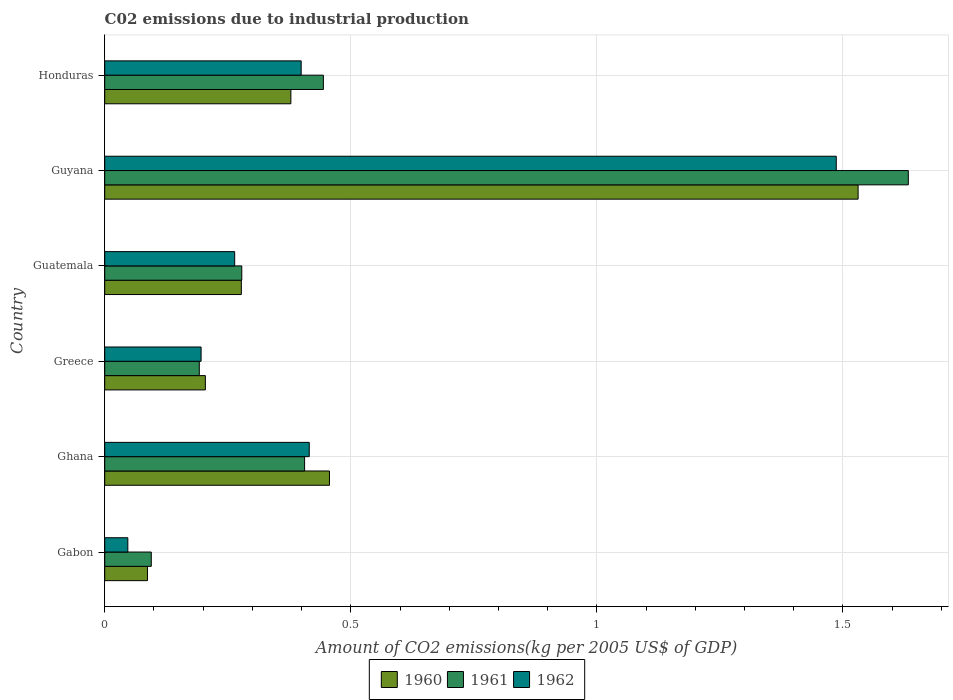How many groups of bars are there?
Keep it short and to the point. 6. What is the label of the 1st group of bars from the top?
Your answer should be very brief. Honduras. In how many cases, is the number of bars for a given country not equal to the number of legend labels?
Your answer should be compact. 0. What is the amount of CO2 emitted due to industrial production in 1961 in Honduras?
Your answer should be very brief. 0.44. Across all countries, what is the maximum amount of CO2 emitted due to industrial production in 1960?
Offer a terse response. 1.53. Across all countries, what is the minimum amount of CO2 emitted due to industrial production in 1960?
Your answer should be compact. 0.09. In which country was the amount of CO2 emitted due to industrial production in 1962 maximum?
Keep it short and to the point. Guyana. In which country was the amount of CO2 emitted due to industrial production in 1960 minimum?
Offer a terse response. Gabon. What is the total amount of CO2 emitted due to industrial production in 1962 in the graph?
Ensure brevity in your answer.  2.81. What is the difference between the amount of CO2 emitted due to industrial production in 1960 in Guatemala and that in Honduras?
Ensure brevity in your answer.  -0.1. What is the difference between the amount of CO2 emitted due to industrial production in 1962 in Guyana and the amount of CO2 emitted due to industrial production in 1961 in Greece?
Make the answer very short. 1.29. What is the average amount of CO2 emitted due to industrial production in 1962 per country?
Offer a terse response. 0.47. What is the difference between the amount of CO2 emitted due to industrial production in 1962 and amount of CO2 emitted due to industrial production in 1961 in Ghana?
Ensure brevity in your answer.  0.01. What is the ratio of the amount of CO2 emitted due to industrial production in 1961 in Greece to that in Guatemala?
Ensure brevity in your answer.  0.69. Is the amount of CO2 emitted due to industrial production in 1960 in Greece less than that in Guyana?
Ensure brevity in your answer.  Yes. Is the difference between the amount of CO2 emitted due to industrial production in 1962 in Gabon and Guatemala greater than the difference between the amount of CO2 emitted due to industrial production in 1961 in Gabon and Guatemala?
Give a very brief answer. No. What is the difference between the highest and the second highest amount of CO2 emitted due to industrial production in 1960?
Offer a very short reply. 1.07. What is the difference between the highest and the lowest amount of CO2 emitted due to industrial production in 1961?
Ensure brevity in your answer.  1.54. What does the 1st bar from the top in Honduras represents?
Keep it short and to the point. 1962. What does the 3rd bar from the bottom in Guatemala represents?
Provide a succinct answer. 1962. Are all the bars in the graph horizontal?
Give a very brief answer. Yes. How many countries are there in the graph?
Your answer should be compact. 6. Are the values on the major ticks of X-axis written in scientific E-notation?
Your answer should be very brief. No. Does the graph contain grids?
Offer a terse response. Yes. What is the title of the graph?
Your answer should be compact. C02 emissions due to industrial production. Does "2001" appear as one of the legend labels in the graph?
Your answer should be compact. No. What is the label or title of the X-axis?
Offer a very short reply. Amount of CO2 emissions(kg per 2005 US$ of GDP). What is the Amount of CO2 emissions(kg per 2005 US$ of GDP) in 1960 in Gabon?
Provide a short and direct response. 0.09. What is the Amount of CO2 emissions(kg per 2005 US$ of GDP) of 1961 in Gabon?
Offer a terse response. 0.09. What is the Amount of CO2 emissions(kg per 2005 US$ of GDP) in 1962 in Gabon?
Your answer should be very brief. 0.05. What is the Amount of CO2 emissions(kg per 2005 US$ of GDP) of 1960 in Ghana?
Offer a terse response. 0.46. What is the Amount of CO2 emissions(kg per 2005 US$ of GDP) of 1961 in Ghana?
Offer a very short reply. 0.41. What is the Amount of CO2 emissions(kg per 2005 US$ of GDP) in 1962 in Ghana?
Your answer should be compact. 0.42. What is the Amount of CO2 emissions(kg per 2005 US$ of GDP) of 1960 in Greece?
Offer a terse response. 0.2. What is the Amount of CO2 emissions(kg per 2005 US$ of GDP) of 1961 in Greece?
Ensure brevity in your answer.  0.19. What is the Amount of CO2 emissions(kg per 2005 US$ of GDP) of 1962 in Greece?
Your answer should be compact. 0.2. What is the Amount of CO2 emissions(kg per 2005 US$ of GDP) in 1960 in Guatemala?
Your answer should be very brief. 0.28. What is the Amount of CO2 emissions(kg per 2005 US$ of GDP) of 1961 in Guatemala?
Give a very brief answer. 0.28. What is the Amount of CO2 emissions(kg per 2005 US$ of GDP) of 1962 in Guatemala?
Your answer should be compact. 0.26. What is the Amount of CO2 emissions(kg per 2005 US$ of GDP) of 1960 in Guyana?
Keep it short and to the point. 1.53. What is the Amount of CO2 emissions(kg per 2005 US$ of GDP) of 1961 in Guyana?
Offer a very short reply. 1.63. What is the Amount of CO2 emissions(kg per 2005 US$ of GDP) of 1962 in Guyana?
Keep it short and to the point. 1.49. What is the Amount of CO2 emissions(kg per 2005 US$ of GDP) of 1960 in Honduras?
Provide a succinct answer. 0.38. What is the Amount of CO2 emissions(kg per 2005 US$ of GDP) of 1961 in Honduras?
Offer a very short reply. 0.44. What is the Amount of CO2 emissions(kg per 2005 US$ of GDP) of 1962 in Honduras?
Ensure brevity in your answer.  0.4. Across all countries, what is the maximum Amount of CO2 emissions(kg per 2005 US$ of GDP) of 1960?
Provide a succinct answer. 1.53. Across all countries, what is the maximum Amount of CO2 emissions(kg per 2005 US$ of GDP) in 1961?
Provide a succinct answer. 1.63. Across all countries, what is the maximum Amount of CO2 emissions(kg per 2005 US$ of GDP) of 1962?
Offer a terse response. 1.49. Across all countries, what is the minimum Amount of CO2 emissions(kg per 2005 US$ of GDP) in 1960?
Keep it short and to the point. 0.09. Across all countries, what is the minimum Amount of CO2 emissions(kg per 2005 US$ of GDP) of 1961?
Keep it short and to the point. 0.09. Across all countries, what is the minimum Amount of CO2 emissions(kg per 2005 US$ of GDP) in 1962?
Your response must be concise. 0.05. What is the total Amount of CO2 emissions(kg per 2005 US$ of GDP) of 1960 in the graph?
Keep it short and to the point. 2.93. What is the total Amount of CO2 emissions(kg per 2005 US$ of GDP) in 1961 in the graph?
Provide a succinct answer. 3.05. What is the total Amount of CO2 emissions(kg per 2005 US$ of GDP) of 1962 in the graph?
Give a very brief answer. 2.81. What is the difference between the Amount of CO2 emissions(kg per 2005 US$ of GDP) of 1960 in Gabon and that in Ghana?
Ensure brevity in your answer.  -0.37. What is the difference between the Amount of CO2 emissions(kg per 2005 US$ of GDP) of 1961 in Gabon and that in Ghana?
Your answer should be very brief. -0.31. What is the difference between the Amount of CO2 emissions(kg per 2005 US$ of GDP) in 1962 in Gabon and that in Ghana?
Keep it short and to the point. -0.37. What is the difference between the Amount of CO2 emissions(kg per 2005 US$ of GDP) in 1960 in Gabon and that in Greece?
Make the answer very short. -0.12. What is the difference between the Amount of CO2 emissions(kg per 2005 US$ of GDP) in 1961 in Gabon and that in Greece?
Keep it short and to the point. -0.1. What is the difference between the Amount of CO2 emissions(kg per 2005 US$ of GDP) in 1962 in Gabon and that in Greece?
Offer a very short reply. -0.15. What is the difference between the Amount of CO2 emissions(kg per 2005 US$ of GDP) in 1960 in Gabon and that in Guatemala?
Your answer should be very brief. -0.19. What is the difference between the Amount of CO2 emissions(kg per 2005 US$ of GDP) of 1961 in Gabon and that in Guatemala?
Your response must be concise. -0.18. What is the difference between the Amount of CO2 emissions(kg per 2005 US$ of GDP) in 1962 in Gabon and that in Guatemala?
Your response must be concise. -0.22. What is the difference between the Amount of CO2 emissions(kg per 2005 US$ of GDP) in 1960 in Gabon and that in Guyana?
Offer a terse response. -1.44. What is the difference between the Amount of CO2 emissions(kg per 2005 US$ of GDP) in 1961 in Gabon and that in Guyana?
Ensure brevity in your answer.  -1.54. What is the difference between the Amount of CO2 emissions(kg per 2005 US$ of GDP) in 1962 in Gabon and that in Guyana?
Make the answer very short. -1.44. What is the difference between the Amount of CO2 emissions(kg per 2005 US$ of GDP) of 1960 in Gabon and that in Honduras?
Your response must be concise. -0.29. What is the difference between the Amount of CO2 emissions(kg per 2005 US$ of GDP) of 1961 in Gabon and that in Honduras?
Your answer should be compact. -0.35. What is the difference between the Amount of CO2 emissions(kg per 2005 US$ of GDP) of 1962 in Gabon and that in Honduras?
Keep it short and to the point. -0.35. What is the difference between the Amount of CO2 emissions(kg per 2005 US$ of GDP) of 1960 in Ghana and that in Greece?
Offer a very short reply. 0.25. What is the difference between the Amount of CO2 emissions(kg per 2005 US$ of GDP) in 1961 in Ghana and that in Greece?
Ensure brevity in your answer.  0.21. What is the difference between the Amount of CO2 emissions(kg per 2005 US$ of GDP) in 1962 in Ghana and that in Greece?
Ensure brevity in your answer.  0.22. What is the difference between the Amount of CO2 emissions(kg per 2005 US$ of GDP) of 1960 in Ghana and that in Guatemala?
Your answer should be compact. 0.18. What is the difference between the Amount of CO2 emissions(kg per 2005 US$ of GDP) in 1961 in Ghana and that in Guatemala?
Keep it short and to the point. 0.13. What is the difference between the Amount of CO2 emissions(kg per 2005 US$ of GDP) in 1962 in Ghana and that in Guatemala?
Your answer should be compact. 0.15. What is the difference between the Amount of CO2 emissions(kg per 2005 US$ of GDP) of 1960 in Ghana and that in Guyana?
Ensure brevity in your answer.  -1.07. What is the difference between the Amount of CO2 emissions(kg per 2005 US$ of GDP) of 1961 in Ghana and that in Guyana?
Provide a short and direct response. -1.23. What is the difference between the Amount of CO2 emissions(kg per 2005 US$ of GDP) of 1962 in Ghana and that in Guyana?
Provide a short and direct response. -1.07. What is the difference between the Amount of CO2 emissions(kg per 2005 US$ of GDP) in 1960 in Ghana and that in Honduras?
Give a very brief answer. 0.08. What is the difference between the Amount of CO2 emissions(kg per 2005 US$ of GDP) of 1961 in Ghana and that in Honduras?
Offer a very short reply. -0.04. What is the difference between the Amount of CO2 emissions(kg per 2005 US$ of GDP) in 1962 in Ghana and that in Honduras?
Keep it short and to the point. 0.02. What is the difference between the Amount of CO2 emissions(kg per 2005 US$ of GDP) in 1960 in Greece and that in Guatemala?
Offer a terse response. -0.07. What is the difference between the Amount of CO2 emissions(kg per 2005 US$ of GDP) of 1961 in Greece and that in Guatemala?
Your response must be concise. -0.09. What is the difference between the Amount of CO2 emissions(kg per 2005 US$ of GDP) of 1962 in Greece and that in Guatemala?
Make the answer very short. -0.07. What is the difference between the Amount of CO2 emissions(kg per 2005 US$ of GDP) of 1960 in Greece and that in Guyana?
Give a very brief answer. -1.33. What is the difference between the Amount of CO2 emissions(kg per 2005 US$ of GDP) of 1961 in Greece and that in Guyana?
Your answer should be very brief. -1.44. What is the difference between the Amount of CO2 emissions(kg per 2005 US$ of GDP) in 1962 in Greece and that in Guyana?
Provide a succinct answer. -1.29. What is the difference between the Amount of CO2 emissions(kg per 2005 US$ of GDP) in 1960 in Greece and that in Honduras?
Provide a short and direct response. -0.17. What is the difference between the Amount of CO2 emissions(kg per 2005 US$ of GDP) of 1961 in Greece and that in Honduras?
Your answer should be very brief. -0.25. What is the difference between the Amount of CO2 emissions(kg per 2005 US$ of GDP) in 1962 in Greece and that in Honduras?
Ensure brevity in your answer.  -0.2. What is the difference between the Amount of CO2 emissions(kg per 2005 US$ of GDP) of 1960 in Guatemala and that in Guyana?
Your answer should be compact. -1.25. What is the difference between the Amount of CO2 emissions(kg per 2005 US$ of GDP) in 1961 in Guatemala and that in Guyana?
Your response must be concise. -1.35. What is the difference between the Amount of CO2 emissions(kg per 2005 US$ of GDP) of 1962 in Guatemala and that in Guyana?
Give a very brief answer. -1.22. What is the difference between the Amount of CO2 emissions(kg per 2005 US$ of GDP) of 1960 in Guatemala and that in Honduras?
Provide a succinct answer. -0.1. What is the difference between the Amount of CO2 emissions(kg per 2005 US$ of GDP) in 1961 in Guatemala and that in Honduras?
Provide a short and direct response. -0.17. What is the difference between the Amount of CO2 emissions(kg per 2005 US$ of GDP) of 1962 in Guatemala and that in Honduras?
Ensure brevity in your answer.  -0.14. What is the difference between the Amount of CO2 emissions(kg per 2005 US$ of GDP) in 1960 in Guyana and that in Honduras?
Keep it short and to the point. 1.15. What is the difference between the Amount of CO2 emissions(kg per 2005 US$ of GDP) in 1961 in Guyana and that in Honduras?
Provide a short and direct response. 1.19. What is the difference between the Amount of CO2 emissions(kg per 2005 US$ of GDP) of 1962 in Guyana and that in Honduras?
Make the answer very short. 1.09. What is the difference between the Amount of CO2 emissions(kg per 2005 US$ of GDP) in 1960 in Gabon and the Amount of CO2 emissions(kg per 2005 US$ of GDP) in 1961 in Ghana?
Your answer should be compact. -0.32. What is the difference between the Amount of CO2 emissions(kg per 2005 US$ of GDP) in 1960 in Gabon and the Amount of CO2 emissions(kg per 2005 US$ of GDP) in 1962 in Ghana?
Your answer should be compact. -0.33. What is the difference between the Amount of CO2 emissions(kg per 2005 US$ of GDP) of 1961 in Gabon and the Amount of CO2 emissions(kg per 2005 US$ of GDP) of 1962 in Ghana?
Your response must be concise. -0.32. What is the difference between the Amount of CO2 emissions(kg per 2005 US$ of GDP) in 1960 in Gabon and the Amount of CO2 emissions(kg per 2005 US$ of GDP) in 1961 in Greece?
Offer a very short reply. -0.11. What is the difference between the Amount of CO2 emissions(kg per 2005 US$ of GDP) of 1960 in Gabon and the Amount of CO2 emissions(kg per 2005 US$ of GDP) of 1962 in Greece?
Make the answer very short. -0.11. What is the difference between the Amount of CO2 emissions(kg per 2005 US$ of GDP) in 1961 in Gabon and the Amount of CO2 emissions(kg per 2005 US$ of GDP) in 1962 in Greece?
Your answer should be compact. -0.1. What is the difference between the Amount of CO2 emissions(kg per 2005 US$ of GDP) of 1960 in Gabon and the Amount of CO2 emissions(kg per 2005 US$ of GDP) of 1961 in Guatemala?
Provide a succinct answer. -0.19. What is the difference between the Amount of CO2 emissions(kg per 2005 US$ of GDP) in 1960 in Gabon and the Amount of CO2 emissions(kg per 2005 US$ of GDP) in 1962 in Guatemala?
Keep it short and to the point. -0.18. What is the difference between the Amount of CO2 emissions(kg per 2005 US$ of GDP) in 1961 in Gabon and the Amount of CO2 emissions(kg per 2005 US$ of GDP) in 1962 in Guatemala?
Your answer should be compact. -0.17. What is the difference between the Amount of CO2 emissions(kg per 2005 US$ of GDP) of 1960 in Gabon and the Amount of CO2 emissions(kg per 2005 US$ of GDP) of 1961 in Guyana?
Your response must be concise. -1.55. What is the difference between the Amount of CO2 emissions(kg per 2005 US$ of GDP) of 1960 in Gabon and the Amount of CO2 emissions(kg per 2005 US$ of GDP) of 1962 in Guyana?
Offer a terse response. -1.4. What is the difference between the Amount of CO2 emissions(kg per 2005 US$ of GDP) in 1961 in Gabon and the Amount of CO2 emissions(kg per 2005 US$ of GDP) in 1962 in Guyana?
Make the answer very short. -1.39. What is the difference between the Amount of CO2 emissions(kg per 2005 US$ of GDP) in 1960 in Gabon and the Amount of CO2 emissions(kg per 2005 US$ of GDP) in 1961 in Honduras?
Make the answer very short. -0.36. What is the difference between the Amount of CO2 emissions(kg per 2005 US$ of GDP) of 1960 in Gabon and the Amount of CO2 emissions(kg per 2005 US$ of GDP) of 1962 in Honduras?
Offer a terse response. -0.31. What is the difference between the Amount of CO2 emissions(kg per 2005 US$ of GDP) of 1961 in Gabon and the Amount of CO2 emissions(kg per 2005 US$ of GDP) of 1962 in Honduras?
Your response must be concise. -0.3. What is the difference between the Amount of CO2 emissions(kg per 2005 US$ of GDP) of 1960 in Ghana and the Amount of CO2 emissions(kg per 2005 US$ of GDP) of 1961 in Greece?
Make the answer very short. 0.26. What is the difference between the Amount of CO2 emissions(kg per 2005 US$ of GDP) in 1960 in Ghana and the Amount of CO2 emissions(kg per 2005 US$ of GDP) in 1962 in Greece?
Provide a succinct answer. 0.26. What is the difference between the Amount of CO2 emissions(kg per 2005 US$ of GDP) of 1961 in Ghana and the Amount of CO2 emissions(kg per 2005 US$ of GDP) of 1962 in Greece?
Offer a terse response. 0.21. What is the difference between the Amount of CO2 emissions(kg per 2005 US$ of GDP) in 1960 in Ghana and the Amount of CO2 emissions(kg per 2005 US$ of GDP) in 1961 in Guatemala?
Offer a terse response. 0.18. What is the difference between the Amount of CO2 emissions(kg per 2005 US$ of GDP) of 1960 in Ghana and the Amount of CO2 emissions(kg per 2005 US$ of GDP) of 1962 in Guatemala?
Provide a succinct answer. 0.19. What is the difference between the Amount of CO2 emissions(kg per 2005 US$ of GDP) in 1961 in Ghana and the Amount of CO2 emissions(kg per 2005 US$ of GDP) in 1962 in Guatemala?
Give a very brief answer. 0.14. What is the difference between the Amount of CO2 emissions(kg per 2005 US$ of GDP) of 1960 in Ghana and the Amount of CO2 emissions(kg per 2005 US$ of GDP) of 1961 in Guyana?
Provide a succinct answer. -1.18. What is the difference between the Amount of CO2 emissions(kg per 2005 US$ of GDP) of 1960 in Ghana and the Amount of CO2 emissions(kg per 2005 US$ of GDP) of 1962 in Guyana?
Ensure brevity in your answer.  -1.03. What is the difference between the Amount of CO2 emissions(kg per 2005 US$ of GDP) in 1961 in Ghana and the Amount of CO2 emissions(kg per 2005 US$ of GDP) in 1962 in Guyana?
Give a very brief answer. -1.08. What is the difference between the Amount of CO2 emissions(kg per 2005 US$ of GDP) of 1960 in Ghana and the Amount of CO2 emissions(kg per 2005 US$ of GDP) of 1961 in Honduras?
Provide a succinct answer. 0.01. What is the difference between the Amount of CO2 emissions(kg per 2005 US$ of GDP) of 1960 in Ghana and the Amount of CO2 emissions(kg per 2005 US$ of GDP) of 1962 in Honduras?
Ensure brevity in your answer.  0.06. What is the difference between the Amount of CO2 emissions(kg per 2005 US$ of GDP) of 1961 in Ghana and the Amount of CO2 emissions(kg per 2005 US$ of GDP) of 1962 in Honduras?
Provide a succinct answer. 0.01. What is the difference between the Amount of CO2 emissions(kg per 2005 US$ of GDP) in 1960 in Greece and the Amount of CO2 emissions(kg per 2005 US$ of GDP) in 1961 in Guatemala?
Provide a succinct answer. -0.07. What is the difference between the Amount of CO2 emissions(kg per 2005 US$ of GDP) in 1960 in Greece and the Amount of CO2 emissions(kg per 2005 US$ of GDP) in 1962 in Guatemala?
Your answer should be very brief. -0.06. What is the difference between the Amount of CO2 emissions(kg per 2005 US$ of GDP) of 1961 in Greece and the Amount of CO2 emissions(kg per 2005 US$ of GDP) of 1962 in Guatemala?
Your answer should be compact. -0.07. What is the difference between the Amount of CO2 emissions(kg per 2005 US$ of GDP) in 1960 in Greece and the Amount of CO2 emissions(kg per 2005 US$ of GDP) in 1961 in Guyana?
Offer a terse response. -1.43. What is the difference between the Amount of CO2 emissions(kg per 2005 US$ of GDP) of 1960 in Greece and the Amount of CO2 emissions(kg per 2005 US$ of GDP) of 1962 in Guyana?
Your answer should be compact. -1.28. What is the difference between the Amount of CO2 emissions(kg per 2005 US$ of GDP) of 1961 in Greece and the Amount of CO2 emissions(kg per 2005 US$ of GDP) of 1962 in Guyana?
Ensure brevity in your answer.  -1.29. What is the difference between the Amount of CO2 emissions(kg per 2005 US$ of GDP) of 1960 in Greece and the Amount of CO2 emissions(kg per 2005 US$ of GDP) of 1961 in Honduras?
Offer a terse response. -0.24. What is the difference between the Amount of CO2 emissions(kg per 2005 US$ of GDP) of 1960 in Greece and the Amount of CO2 emissions(kg per 2005 US$ of GDP) of 1962 in Honduras?
Give a very brief answer. -0.19. What is the difference between the Amount of CO2 emissions(kg per 2005 US$ of GDP) in 1961 in Greece and the Amount of CO2 emissions(kg per 2005 US$ of GDP) in 1962 in Honduras?
Keep it short and to the point. -0.21. What is the difference between the Amount of CO2 emissions(kg per 2005 US$ of GDP) of 1960 in Guatemala and the Amount of CO2 emissions(kg per 2005 US$ of GDP) of 1961 in Guyana?
Your answer should be compact. -1.36. What is the difference between the Amount of CO2 emissions(kg per 2005 US$ of GDP) of 1960 in Guatemala and the Amount of CO2 emissions(kg per 2005 US$ of GDP) of 1962 in Guyana?
Provide a succinct answer. -1.21. What is the difference between the Amount of CO2 emissions(kg per 2005 US$ of GDP) of 1961 in Guatemala and the Amount of CO2 emissions(kg per 2005 US$ of GDP) of 1962 in Guyana?
Keep it short and to the point. -1.21. What is the difference between the Amount of CO2 emissions(kg per 2005 US$ of GDP) in 1960 in Guatemala and the Amount of CO2 emissions(kg per 2005 US$ of GDP) in 1961 in Honduras?
Your response must be concise. -0.17. What is the difference between the Amount of CO2 emissions(kg per 2005 US$ of GDP) in 1960 in Guatemala and the Amount of CO2 emissions(kg per 2005 US$ of GDP) in 1962 in Honduras?
Make the answer very short. -0.12. What is the difference between the Amount of CO2 emissions(kg per 2005 US$ of GDP) of 1961 in Guatemala and the Amount of CO2 emissions(kg per 2005 US$ of GDP) of 1962 in Honduras?
Make the answer very short. -0.12. What is the difference between the Amount of CO2 emissions(kg per 2005 US$ of GDP) in 1960 in Guyana and the Amount of CO2 emissions(kg per 2005 US$ of GDP) in 1961 in Honduras?
Your response must be concise. 1.09. What is the difference between the Amount of CO2 emissions(kg per 2005 US$ of GDP) in 1960 in Guyana and the Amount of CO2 emissions(kg per 2005 US$ of GDP) in 1962 in Honduras?
Give a very brief answer. 1.13. What is the difference between the Amount of CO2 emissions(kg per 2005 US$ of GDP) of 1961 in Guyana and the Amount of CO2 emissions(kg per 2005 US$ of GDP) of 1962 in Honduras?
Your response must be concise. 1.23. What is the average Amount of CO2 emissions(kg per 2005 US$ of GDP) in 1960 per country?
Your answer should be compact. 0.49. What is the average Amount of CO2 emissions(kg per 2005 US$ of GDP) of 1961 per country?
Your answer should be compact. 0.51. What is the average Amount of CO2 emissions(kg per 2005 US$ of GDP) in 1962 per country?
Keep it short and to the point. 0.47. What is the difference between the Amount of CO2 emissions(kg per 2005 US$ of GDP) in 1960 and Amount of CO2 emissions(kg per 2005 US$ of GDP) in 1961 in Gabon?
Give a very brief answer. -0.01. What is the difference between the Amount of CO2 emissions(kg per 2005 US$ of GDP) in 1960 and Amount of CO2 emissions(kg per 2005 US$ of GDP) in 1962 in Gabon?
Your answer should be compact. 0.04. What is the difference between the Amount of CO2 emissions(kg per 2005 US$ of GDP) in 1961 and Amount of CO2 emissions(kg per 2005 US$ of GDP) in 1962 in Gabon?
Provide a succinct answer. 0.05. What is the difference between the Amount of CO2 emissions(kg per 2005 US$ of GDP) of 1960 and Amount of CO2 emissions(kg per 2005 US$ of GDP) of 1961 in Ghana?
Give a very brief answer. 0.05. What is the difference between the Amount of CO2 emissions(kg per 2005 US$ of GDP) of 1960 and Amount of CO2 emissions(kg per 2005 US$ of GDP) of 1962 in Ghana?
Your answer should be very brief. 0.04. What is the difference between the Amount of CO2 emissions(kg per 2005 US$ of GDP) of 1961 and Amount of CO2 emissions(kg per 2005 US$ of GDP) of 1962 in Ghana?
Provide a short and direct response. -0.01. What is the difference between the Amount of CO2 emissions(kg per 2005 US$ of GDP) in 1960 and Amount of CO2 emissions(kg per 2005 US$ of GDP) in 1961 in Greece?
Make the answer very short. 0.01. What is the difference between the Amount of CO2 emissions(kg per 2005 US$ of GDP) in 1960 and Amount of CO2 emissions(kg per 2005 US$ of GDP) in 1962 in Greece?
Provide a succinct answer. 0.01. What is the difference between the Amount of CO2 emissions(kg per 2005 US$ of GDP) in 1961 and Amount of CO2 emissions(kg per 2005 US$ of GDP) in 1962 in Greece?
Ensure brevity in your answer.  -0. What is the difference between the Amount of CO2 emissions(kg per 2005 US$ of GDP) in 1960 and Amount of CO2 emissions(kg per 2005 US$ of GDP) in 1961 in Guatemala?
Your response must be concise. -0. What is the difference between the Amount of CO2 emissions(kg per 2005 US$ of GDP) of 1960 and Amount of CO2 emissions(kg per 2005 US$ of GDP) of 1962 in Guatemala?
Make the answer very short. 0.01. What is the difference between the Amount of CO2 emissions(kg per 2005 US$ of GDP) in 1961 and Amount of CO2 emissions(kg per 2005 US$ of GDP) in 1962 in Guatemala?
Provide a succinct answer. 0.01. What is the difference between the Amount of CO2 emissions(kg per 2005 US$ of GDP) of 1960 and Amount of CO2 emissions(kg per 2005 US$ of GDP) of 1961 in Guyana?
Give a very brief answer. -0.1. What is the difference between the Amount of CO2 emissions(kg per 2005 US$ of GDP) in 1960 and Amount of CO2 emissions(kg per 2005 US$ of GDP) in 1962 in Guyana?
Provide a short and direct response. 0.04. What is the difference between the Amount of CO2 emissions(kg per 2005 US$ of GDP) in 1961 and Amount of CO2 emissions(kg per 2005 US$ of GDP) in 1962 in Guyana?
Keep it short and to the point. 0.15. What is the difference between the Amount of CO2 emissions(kg per 2005 US$ of GDP) of 1960 and Amount of CO2 emissions(kg per 2005 US$ of GDP) of 1961 in Honduras?
Provide a short and direct response. -0.07. What is the difference between the Amount of CO2 emissions(kg per 2005 US$ of GDP) in 1960 and Amount of CO2 emissions(kg per 2005 US$ of GDP) in 1962 in Honduras?
Provide a succinct answer. -0.02. What is the difference between the Amount of CO2 emissions(kg per 2005 US$ of GDP) of 1961 and Amount of CO2 emissions(kg per 2005 US$ of GDP) of 1962 in Honduras?
Offer a terse response. 0.05. What is the ratio of the Amount of CO2 emissions(kg per 2005 US$ of GDP) in 1960 in Gabon to that in Ghana?
Provide a short and direct response. 0.19. What is the ratio of the Amount of CO2 emissions(kg per 2005 US$ of GDP) of 1961 in Gabon to that in Ghana?
Provide a short and direct response. 0.23. What is the ratio of the Amount of CO2 emissions(kg per 2005 US$ of GDP) in 1962 in Gabon to that in Ghana?
Provide a short and direct response. 0.11. What is the ratio of the Amount of CO2 emissions(kg per 2005 US$ of GDP) in 1960 in Gabon to that in Greece?
Your answer should be compact. 0.42. What is the ratio of the Amount of CO2 emissions(kg per 2005 US$ of GDP) in 1961 in Gabon to that in Greece?
Provide a short and direct response. 0.49. What is the ratio of the Amount of CO2 emissions(kg per 2005 US$ of GDP) in 1962 in Gabon to that in Greece?
Offer a very short reply. 0.24. What is the ratio of the Amount of CO2 emissions(kg per 2005 US$ of GDP) in 1960 in Gabon to that in Guatemala?
Your answer should be compact. 0.31. What is the ratio of the Amount of CO2 emissions(kg per 2005 US$ of GDP) in 1961 in Gabon to that in Guatemala?
Give a very brief answer. 0.34. What is the ratio of the Amount of CO2 emissions(kg per 2005 US$ of GDP) of 1962 in Gabon to that in Guatemala?
Your answer should be very brief. 0.18. What is the ratio of the Amount of CO2 emissions(kg per 2005 US$ of GDP) of 1960 in Gabon to that in Guyana?
Offer a very short reply. 0.06. What is the ratio of the Amount of CO2 emissions(kg per 2005 US$ of GDP) in 1961 in Gabon to that in Guyana?
Make the answer very short. 0.06. What is the ratio of the Amount of CO2 emissions(kg per 2005 US$ of GDP) in 1962 in Gabon to that in Guyana?
Ensure brevity in your answer.  0.03. What is the ratio of the Amount of CO2 emissions(kg per 2005 US$ of GDP) in 1960 in Gabon to that in Honduras?
Offer a very short reply. 0.23. What is the ratio of the Amount of CO2 emissions(kg per 2005 US$ of GDP) of 1961 in Gabon to that in Honduras?
Your answer should be compact. 0.21. What is the ratio of the Amount of CO2 emissions(kg per 2005 US$ of GDP) in 1962 in Gabon to that in Honduras?
Your answer should be very brief. 0.12. What is the ratio of the Amount of CO2 emissions(kg per 2005 US$ of GDP) in 1960 in Ghana to that in Greece?
Make the answer very short. 2.23. What is the ratio of the Amount of CO2 emissions(kg per 2005 US$ of GDP) in 1961 in Ghana to that in Greece?
Provide a succinct answer. 2.11. What is the ratio of the Amount of CO2 emissions(kg per 2005 US$ of GDP) of 1962 in Ghana to that in Greece?
Your response must be concise. 2.12. What is the ratio of the Amount of CO2 emissions(kg per 2005 US$ of GDP) of 1960 in Ghana to that in Guatemala?
Your answer should be very brief. 1.65. What is the ratio of the Amount of CO2 emissions(kg per 2005 US$ of GDP) in 1961 in Ghana to that in Guatemala?
Your response must be concise. 1.46. What is the ratio of the Amount of CO2 emissions(kg per 2005 US$ of GDP) in 1962 in Ghana to that in Guatemala?
Offer a very short reply. 1.57. What is the ratio of the Amount of CO2 emissions(kg per 2005 US$ of GDP) of 1960 in Ghana to that in Guyana?
Keep it short and to the point. 0.3. What is the ratio of the Amount of CO2 emissions(kg per 2005 US$ of GDP) of 1961 in Ghana to that in Guyana?
Give a very brief answer. 0.25. What is the ratio of the Amount of CO2 emissions(kg per 2005 US$ of GDP) in 1962 in Ghana to that in Guyana?
Offer a very short reply. 0.28. What is the ratio of the Amount of CO2 emissions(kg per 2005 US$ of GDP) of 1960 in Ghana to that in Honduras?
Provide a short and direct response. 1.21. What is the ratio of the Amount of CO2 emissions(kg per 2005 US$ of GDP) of 1961 in Ghana to that in Honduras?
Your response must be concise. 0.91. What is the ratio of the Amount of CO2 emissions(kg per 2005 US$ of GDP) of 1962 in Ghana to that in Honduras?
Offer a very short reply. 1.04. What is the ratio of the Amount of CO2 emissions(kg per 2005 US$ of GDP) of 1960 in Greece to that in Guatemala?
Provide a short and direct response. 0.74. What is the ratio of the Amount of CO2 emissions(kg per 2005 US$ of GDP) of 1961 in Greece to that in Guatemala?
Keep it short and to the point. 0.69. What is the ratio of the Amount of CO2 emissions(kg per 2005 US$ of GDP) in 1962 in Greece to that in Guatemala?
Offer a terse response. 0.74. What is the ratio of the Amount of CO2 emissions(kg per 2005 US$ of GDP) in 1960 in Greece to that in Guyana?
Your answer should be compact. 0.13. What is the ratio of the Amount of CO2 emissions(kg per 2005 US$ of GDP) of 1961 in Greece to that in Guyana?
Keep it short and to the point. 0.12. What is the ratio of the Amount of CO2 emissions(kg per 2005 US$ of GDP) in 1962 in Greece to that in Guyana?
Ensure brevity in your answer.  0.13. What is the ratio of the Amount of CO2 emissions(kg per 2005 US$ of GDP) in 1960 in Greece to that in Honduras?
Provide a short and direct response. 0.54. What is the ratio of the Amount of CO2 emissions(kg per 2005 US$ of GDP) of 1961 in Greece to that in Honduras?
Your answer should be compact. 0.43. What is the ratio of the Amount of CO2 emissions(kg per 2005 US$ of GDP) in 1962 in Greece to that in Honduras?
Make the answer very short. 0.49. What is the ratio of the Amount of CO2 emissions(kg per 2005 US$ of GDP) of 1960 in Guatemala to that in Guyana?
Provide a succinct answer. 0.18. What is the ratio of the Amount of CO2 emissions(kg per 2005 US$ of GDP) of 1961 in Guatemala to that in Guyana?
Give a very brief answer. 0.17. What is the ratio of the Amount of CO2 emissions(kg per 2005 US$ of GDP) in 1962 in Guatemala to that in Guyana?
Provide a short and direct response. 0.18. What is the ratio of the Amount of CO2 emissions(kg per 2005 US$ of GDP) in 1960 in Guatemala to that in Honduras?
Your answer should be very brief. 0.73. What is the ratio of the Amount of CO2 emissions(kg per 2005 US$ of GDP) in 1961 in Guatemala to that in Honduras?
Offer a terse response. 0.63. What is the ratio of the Amount of CO2 emissions(kg per 2005 US$ of GDP) of 1962 in Guatemala to that in Honduras?
Provide a short and direct response. 0.66. What is the ratio of the Amount of CO2 emissions(kg per 2005 US$ of GDP) in 1960 in Guyana to that in Honduras?
Ensure brevity in your answer.  4.05. What is the ratio of the Amount of CO2 emissions(kg per 2005 US$ of GDP) in 1961 in Guyana to that in Honduras?
Your response must be concise. 3.68. What is the ratio of the Amount of CO2 emissions(kg per 2005 US$ of GDP) in 1962 in Guyana to that in Honduras?
Offer a very short reply. 3.72. What is the difference between the highest and the second highest Amount of CO2 emissions(kg per 2005 US$ of GDP) of 1960?
Make the answer very short. 1.07. What is the difference between the highest and the second highest Amount of CO2 emissions(kg per 2005 US$ of GDP) in 1961?
Ensure brevity in your answer.  1.19. What is the difference between the highest and the second highest Amount of CO2 emissions(kg per 2005 US$ of GDP) of 1962?
Your response must be concise. 1.07. What is the difference between the highest and the lowest Amount of CO2 emissions(kg per 2005 US$ of GDP) in 1960?
Offer a very short reply. 1.44. What is the difference between the highest and the lowest Amount of CO2 emissions(kg per 2005 US$ of GDP) in 1961?
Your response must be concise. 1.54. What is the difference between the highest and the lowest Amount of CO2 emissions(kg per 2005 US$ of GDP) of 1962?
Offer a very short reply. 1.44. 